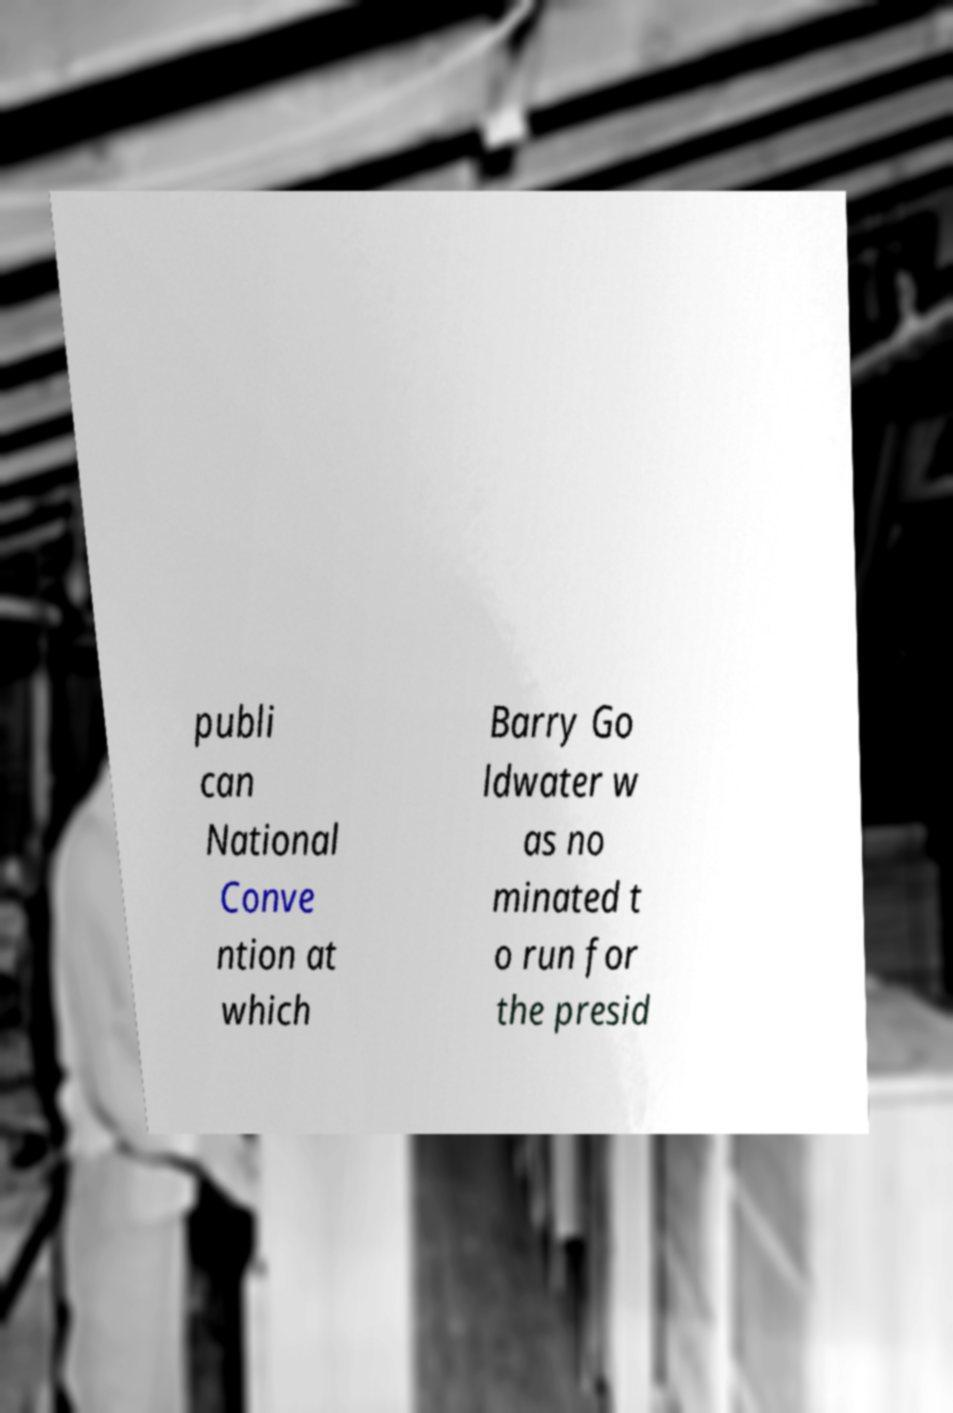Please read and relay the text visible in this image. What does it say? publi can National Conve ntion at which Barry Go ldwater w as no minated t o run for the presid 